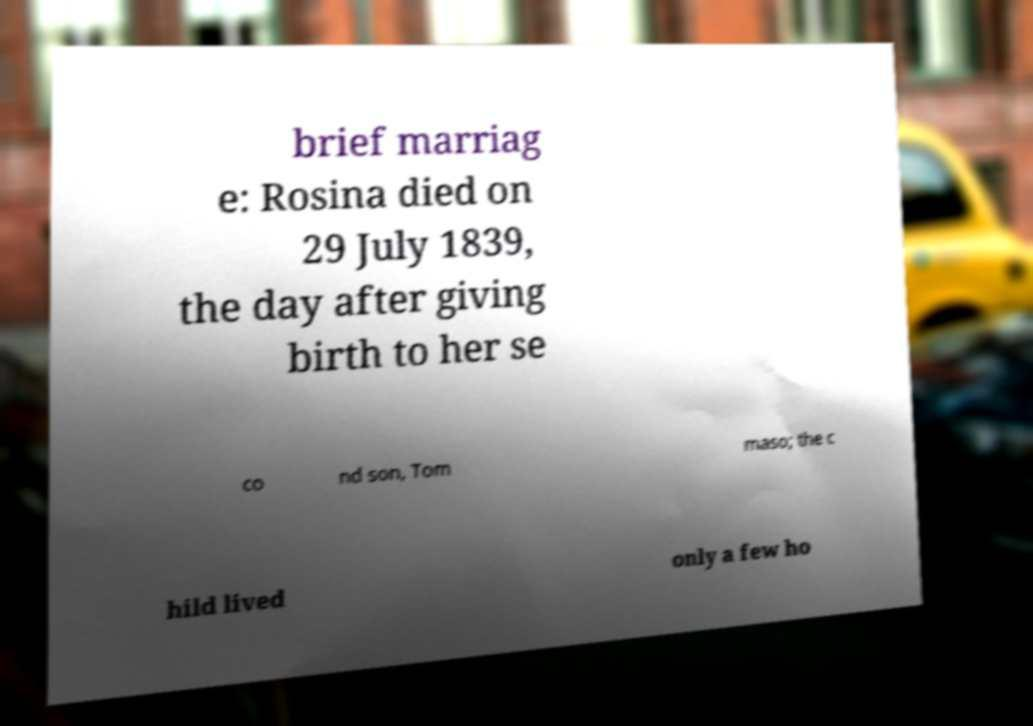What messages or text are displayed in this image? I need them in a readable, typed format. brief marriag e: Rosina died on 29 July 1839, the day after giving birth to her se co nd son, Tom maso; the c hild lived only a few ho 